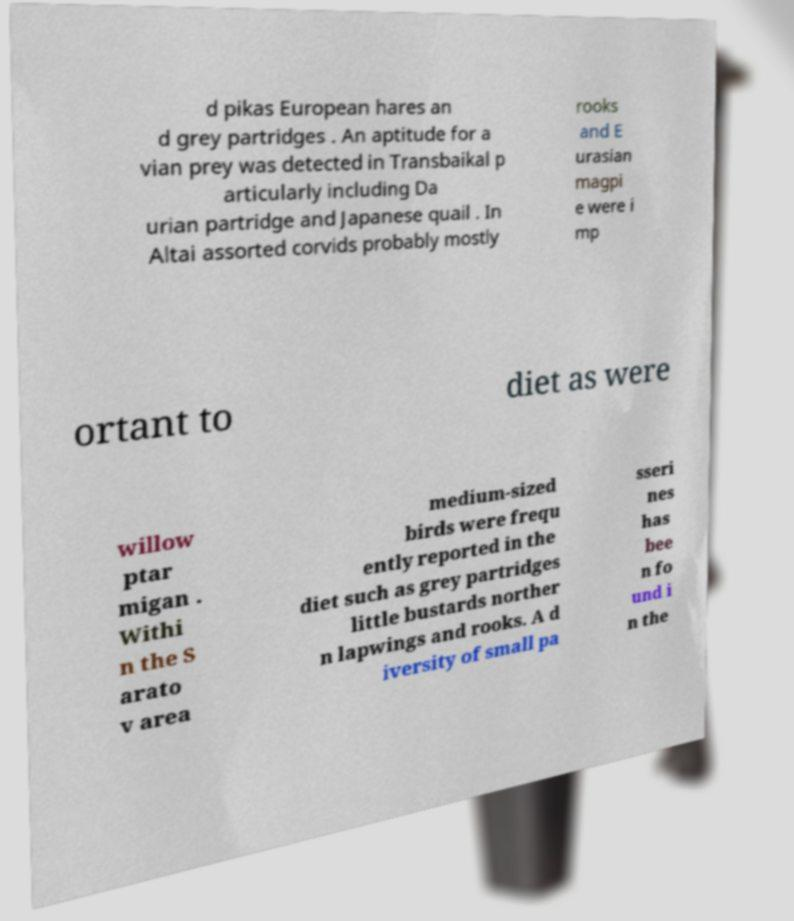What messages or text are displayed in this image? I need them in a readable, typed format. d pikas European hares an d grey partridges . An aptitude for a vian prey was detected in Transbaikal p articularly including Da urian partridge and Japanese quail . In Altai assorted corvids probably mostly rooks and E urasian magpi e were i mp ortant to diet as were willow ptar migan . Withi n the S arato v area medium-sized birds were frequ ently reported in the diet such as grey partridges little bustards norther n lapwings and rooks. A d iversity of small pa sseri nes has bee n fo und i n the 